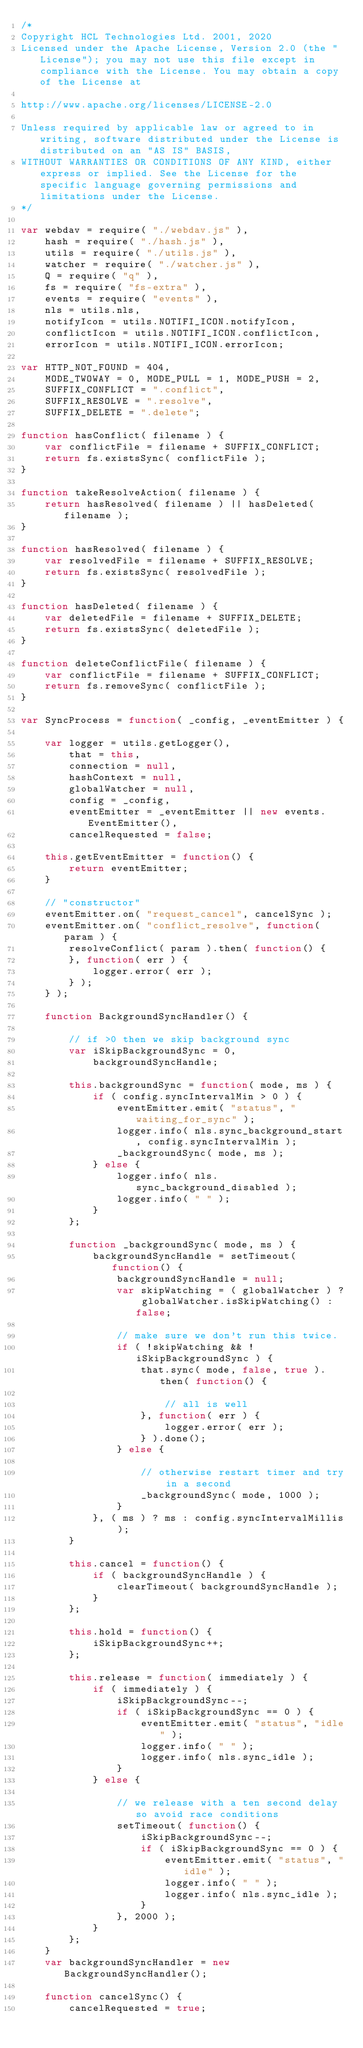<code> <loc_0><loc_0><loc_500><loc_500><_JavaScript_>/*
Copyright HCL Technologies Ltd. 2001, 2020
Licensed under the Apache License, Version 2.0 (the "License"); you may not use this file except in compliance with the License. You may obtain a copy of the License at

http://www.apache.org/licenses/LICENSE-2.0

Unless required by applicable law or agreed to in writing, software distributed under the License is distributed on an "AS IS" BASIS,
WITHOUT WARRANTIES OR CONDITIONS OF ANY KIND, either express or implied. See the License for the specific language governing permissions and limitations under the License.
*/

var webdav = require( "./webdav.js" ),
	hash = require( "./hash.js" ),
	utils = require( "./utils.js" ),
	watcher = require( "./watcher.js" ),
	Q = require( "q" ),
	fs = require( "fs-extra" ),
	events = require( "events" ),
	nls = utils.nls,
	notifyIcon = utils.NOTIFI_ICON.notifyIcon,
	conflictIcon = utils.NOTIFI_ICON.conflictIcon,
	errorIcon = utils.NOTIFI_ICON.errorIcon;

var HTTP_NOT_FOUND = 404,
	MODE_TWOWAY = 0, MODE_PULL = 1, MODE_PUSH = 2,
	SUFFIX_CONFLICT = ".conflict",
	SUFFIX_RESOLVE = ".resolve",
	SUFFIX_DELETE = ".delete";

function hasConflict( filename ) {
	var conflictFile = filename + SUFFIX_CONFLICT;
	return fs.existsSync( conflictFile );
}

function takeResolveAction( filename ) {
	return hasResolved( filename ) || hasDeleted( filename );
}

function hasResolved( filename ) {
	var resolvedFile = filename + SUFFIX_RESOLVE;
	return fs.existsSync( resolvedFile );
}

function hasDeleted( filename ) {
	var deletedFile = filename + SUFFIX_DELETE;
	return fs.existsSync( deletedFile );
}

function deleteConflictFile( filename ) {
	var conflictFile = filename + SUFFIX_CONFLICT;
	return fs.removeSync( conflictFile );
}

var SyncProcess = function( _config, _eventEmitter ) {

	var logger = utils.getLogger(),
		that = this,
		connection = null,
		hashContext = null,
		globalWatcher = null,
		config = _config,
		eventEmitter = _eventEmitter || new events.EventEmitter(),
		cancelRequested = false;

	this.getEventEmitter = function() {
		return eventEmitter;
	}

	// "constructor"
	eventEmitter.on( "request_cancel", cancelSync );
	eventEmitter.on( "conflict_resolve", function( param ) {
		resolveConflict( param ).then( function() {
		}, function( err ) {
			logger.error( err );
		} );
	} );

	function BackgroundSyncHandler() {

		// if >0 then we skip background sync
		var iSkipBackgroundSync = 0,
			backgroundSyncHandle;

		this.backgroundSync = function( mode, ms ) {
			if ( config.syncIntervalMin > 0 ) {
				eventEmitter.emit( "status", "waiting_for_sync" );
				logger.info( nls.sync_background_start, config.syncIntervalMin );
				_backgroundSync( mode, ms );
			} else {
				logger.info( nls.sync_background_disabled );
				logger.info( " " );
			}
		};

		function _backgroundSync( mode, ms ) {
			backgroundSyncHandle = setTimeout( function() {
				backgroundSyncHandle = null;
				var skipWatching = ( globalWatcher ) ? globalWatcher.isSkipWatching() : false;

				// make sure we don't run this twice.
				if ( !skipWatching && !iSkipBackgroundSync ) {
					that.sync( mode, false, true ).then( function() {

						// all is well
					}, function( err ) {
						logger.error( err );
					} ).done();
				} else {

					// otherwise restart timer and try in a second
					_backgroundSync( mode, 1000 );
				}
			}, ( ms ) ? ms : config.syncIntervalMillis );
		}

		this.cancel = function() {
			if ( backgroundSyncHandle ) {
				clearTimeout( backgroundSyncHandle );
			}
		};

		this.hold = function() {
			iSkipBackgroundSync++;
		};

		this.release = function( immediately ) {
			if ( immediately ) {
				iSkipBackgroundSync--;
				if ( iSkipBackgroundSync == 0 ) {
					eventEmitter.emit( "status", "idle" );
					logger.info( " " );
					logger.info( nls.sync_idle );
				}
			} else {

				// we release with a ten second delay so avoid race conditions
				setTimeout( function() {
					iSkipBackgroundSync--;
					if ( iSkipBackgroundSync == 0 ) {
						eventEmitter.emit( "status", "idle" );
						logger.info( " " );
						logger.info( nls.sync_idle );
					}
				}, 2000 );
			}
		};
	}
	var backgroundSyncHandler = new BackgroundSyncHandler();

	function cancelSync() {
		cancelRequested = true;</code> 